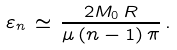Convert formula to latex. <formula><loc_0><loc_0><loc_500><loc_500>\varepsilon _ { n } \, \simeq \, \frac { 2 M _ { 0 } \, R } { \mu \, ( n - 1 ) \, \pi } \, { . }</formula> 